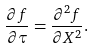<formula> <loc_0><loc_0><loc_500><loc_500>\frac { \partial f } { \partial \tau } = \frac { \partial ^ { 2 } f } { \partial X ^ { 2 } } .</formula> 